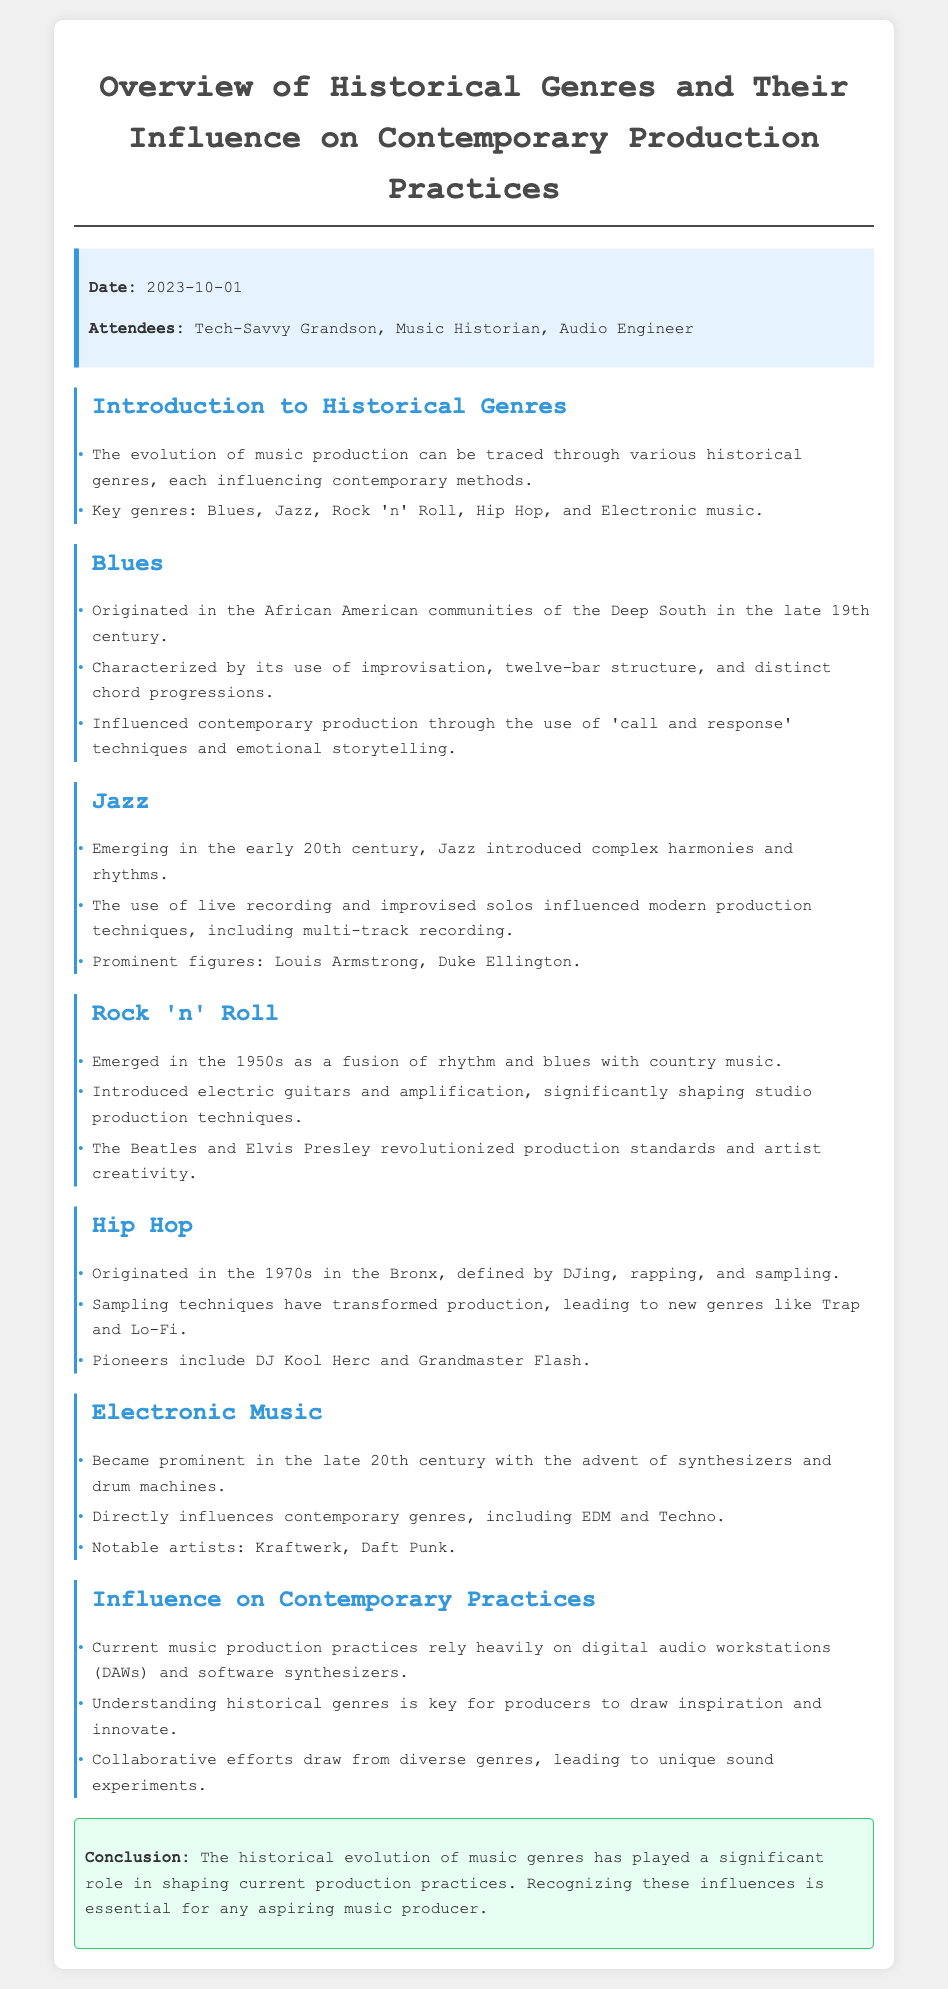What are the key genres mentioned? The document lists key genres that include Blues, Jazz, Rock 'n' Roll, Hip Hop, and Electronic music.
Answer: Blues, Jazz, Rock 'n' Roll, Hip Hop, Electronic music When did Hip Hop originate? According to the document, Hip Hop originated in the 1970s in the Bronx.
Answer: 1970s Who was a prominent figure in Jazz? The document mentions Louis Armstrong as a prominent figure in Jazz.
Answer: Louis Armstrong What technological advancement influenced Electronic music? The document states that synthesizers and drum machines became prominent in the late 20th century, which influenced Electronic music.
Answer: Synthesizers and drum machines What did the Blues influence in contemporary production? The document describes that the Blues influenced contemporary production through 'call and response' techniques and emotional storytelling.
Answer: 'Call and response' techniques and emotional storytelling How has sampling transformed production? The document indicates that sampling techniques have transformed production, leading to new genres like Trap and Lo-Fi.
Answer: New genres like Trap and Lo-Fi What is the conclusion of the meeting about historical genres? The conclusion summarizes that recognizing the influences of historical evolution of music genres is essential for any aspiring music producer.
Answer: Essential for any aspiring music producer What date was the meeting held? The document specifies that the meeting took place on October 1, 2023.
Answer: 2023-10-01 Who attended the meeting? The attendees listed in the document include Tech-Savvy Grandson, Music Historian, and Audio Engineer.
Answer: Tech-Savvy Grandson, Music Historian, Audio Engineer 